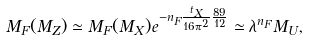<formula> <loc_0><loc_0><loc_500><loc_500>M _ { F } ( M _ { Z } ) \simeq M _ { F } ( M _ { X } ) e ^ { - n _ { F } \frac { t _ { X } } { 1 6 \pi ^ { 2 } } \frac { 8 9 } { 1 2 } } \simeq \lambda ^ { n _ { F } } M _ { U } ,</formula> 